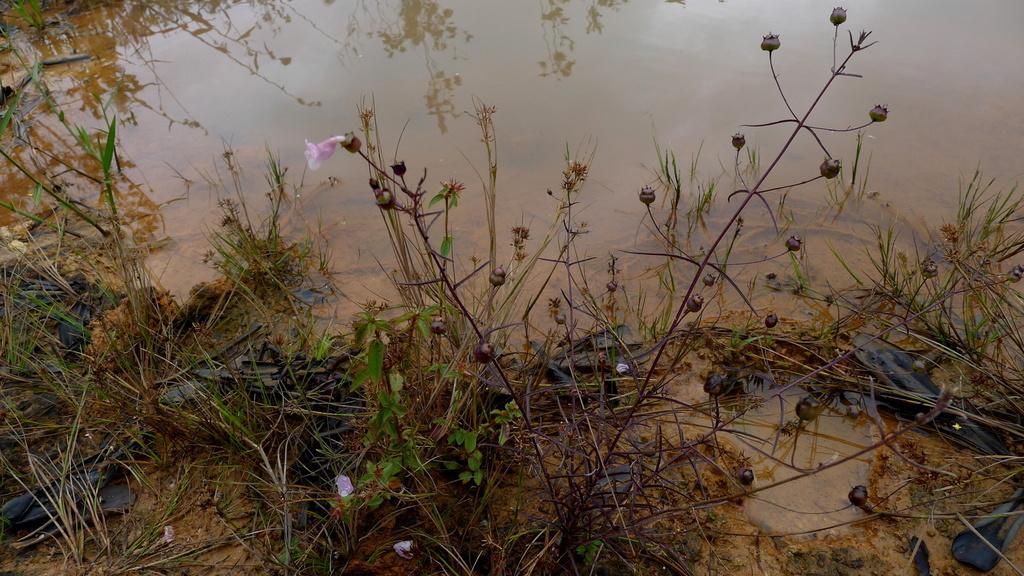In one or two sentences, can you explain what this image depicts? In this picture there are flowers and buds on the plants and there is grass. At the bottom there is mud and water and there are reflections of plants on the water. 